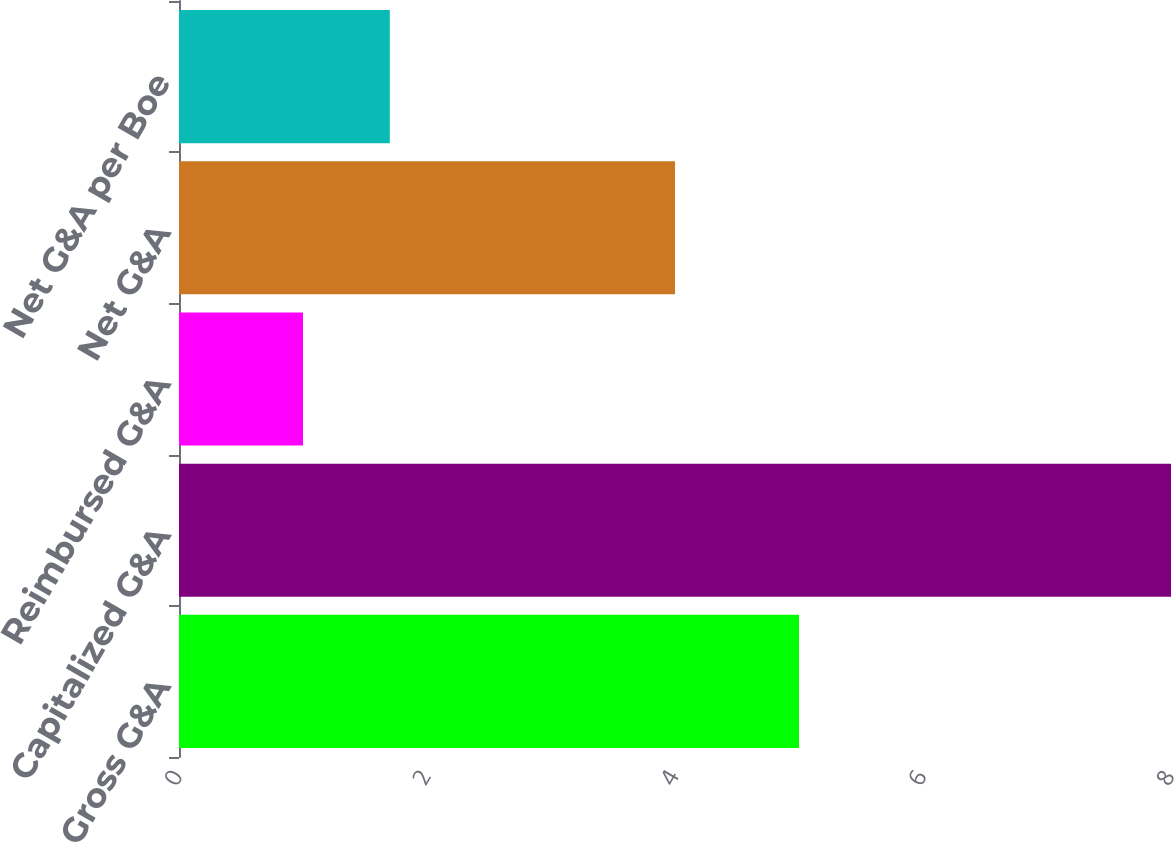<chart> <loc_0><loc_0><loc_500><loc_500><bar_chart><fcel>Gross G&A<fcel>Capitalized G&A<fcel>Reimbursed G&A<fcel>Net G&A<fcel>Net G&A per Boe<nl><fcel>5<fcel>8<fcel>1<fcel>4<fcel>1.7<nl></chart> 